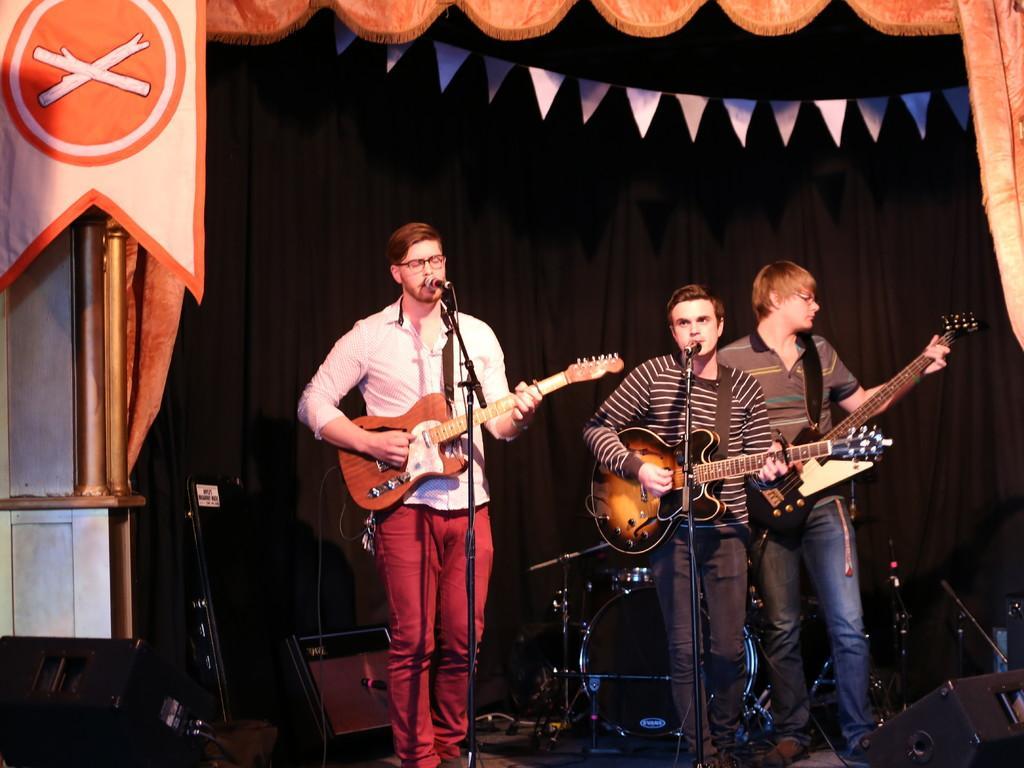Describe this image in one or two sentences. This picture is of inside in the foreground we can see the three persons standing and playing guitar. There are microphones attached to the stand. In the background we can see the musical instruments, black color curtain and poles 